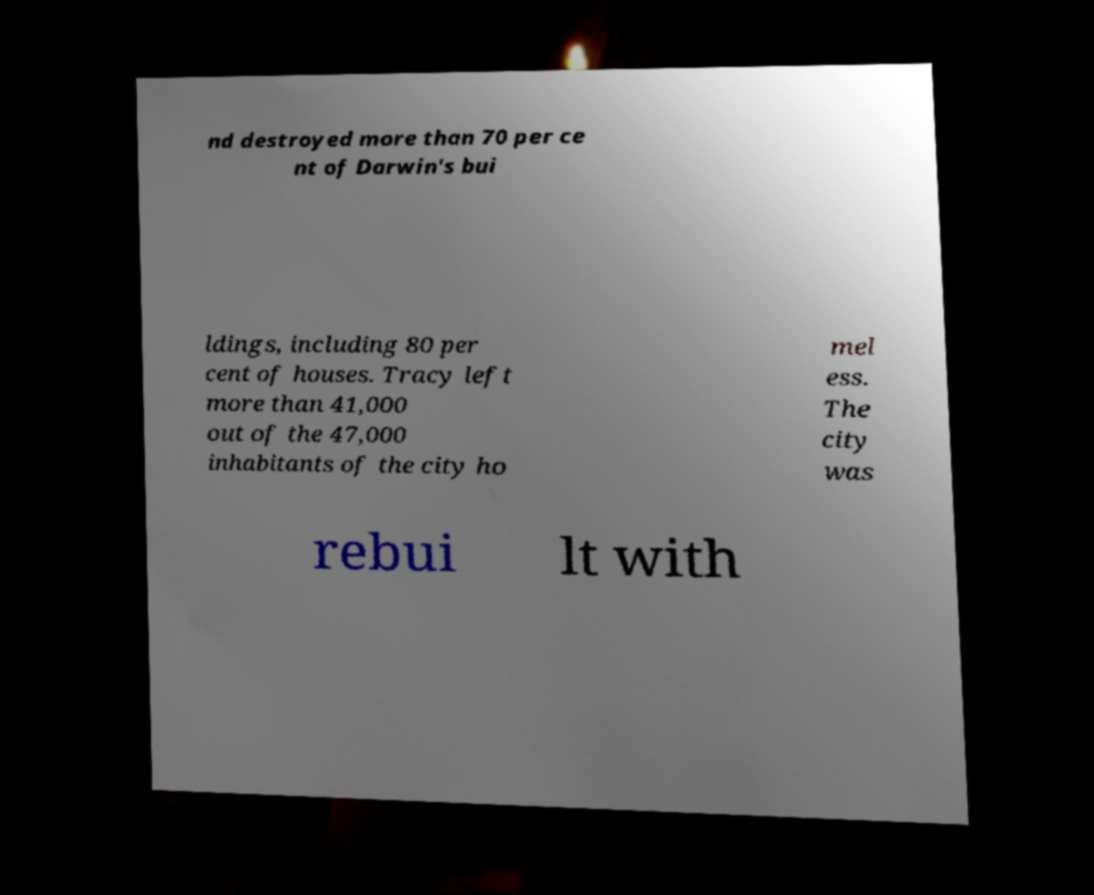Can you accurately transcribe the text from the provided image for me? nd destroyed more than 70 per ce nt of Darwin's bui ldings, including 80 per cent of houses. Tracy left more than 41,000 out of the 47,000 inhabitants of the city ho mel ess. The city was rebui lt with 